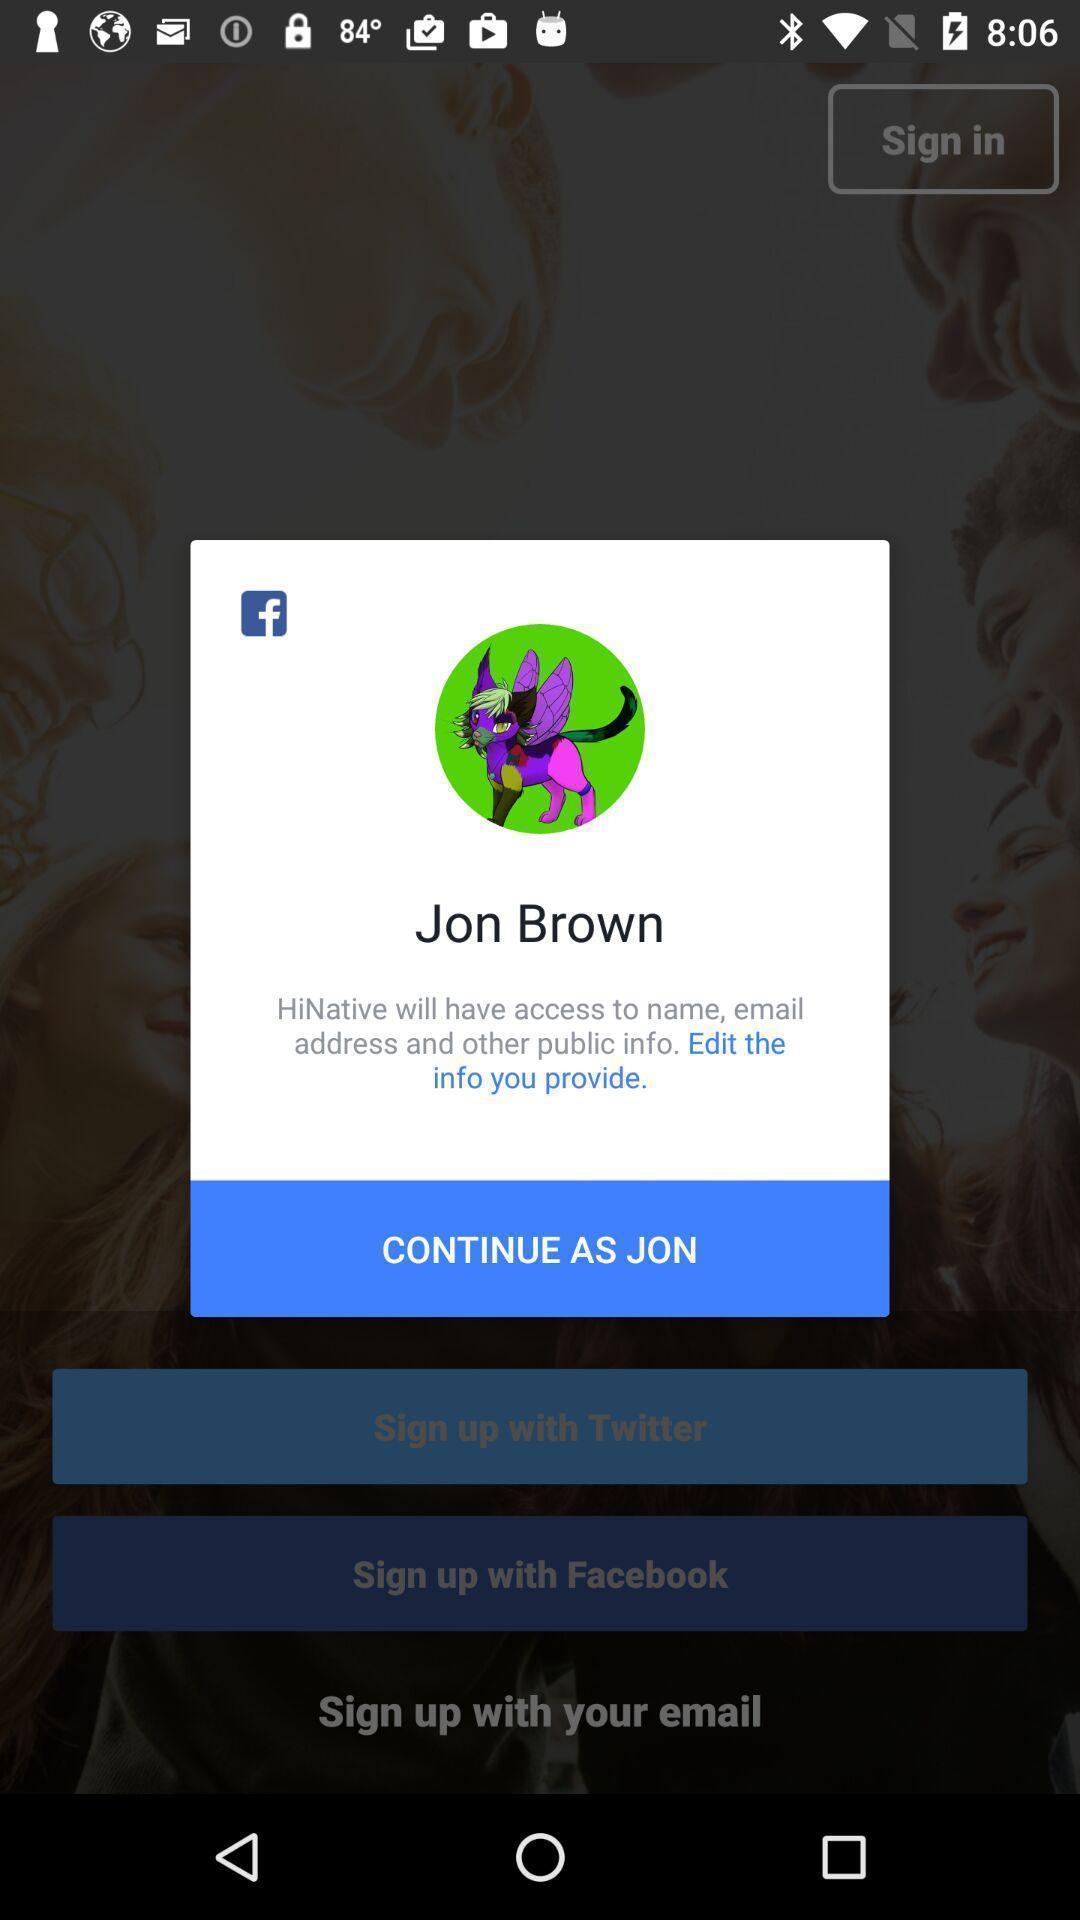What details can you identify in this image? Popup of profile to continue with same credentials. 